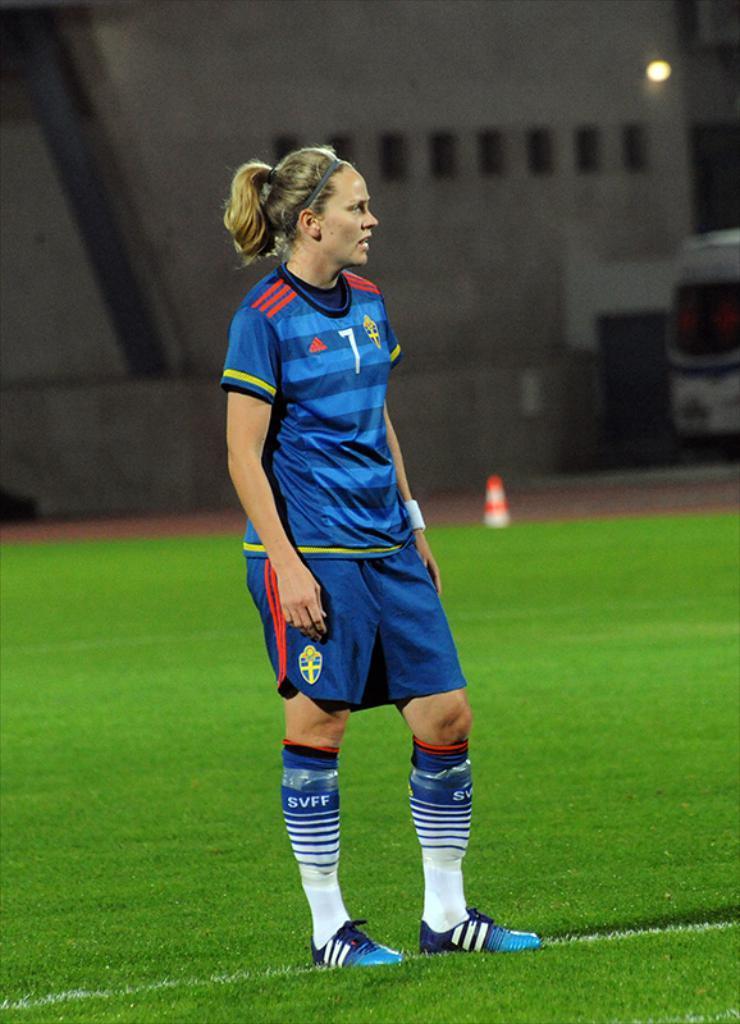Could you give a brief overview of what you see in this image? In this image in the foreground there is one woman standing, and she is wearing jersey. At the bottom there is grass and in the background there is a vehicle, barricade, light and a building. 